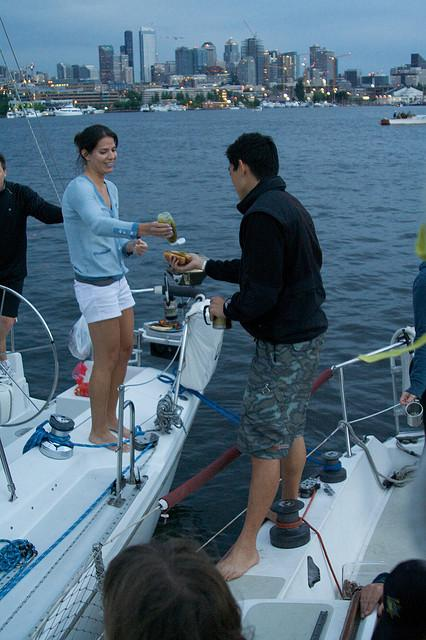What kind of sauce is this?

Choices:
A) hot sauce
B) relish
C) mustard
D) ketchup relish 